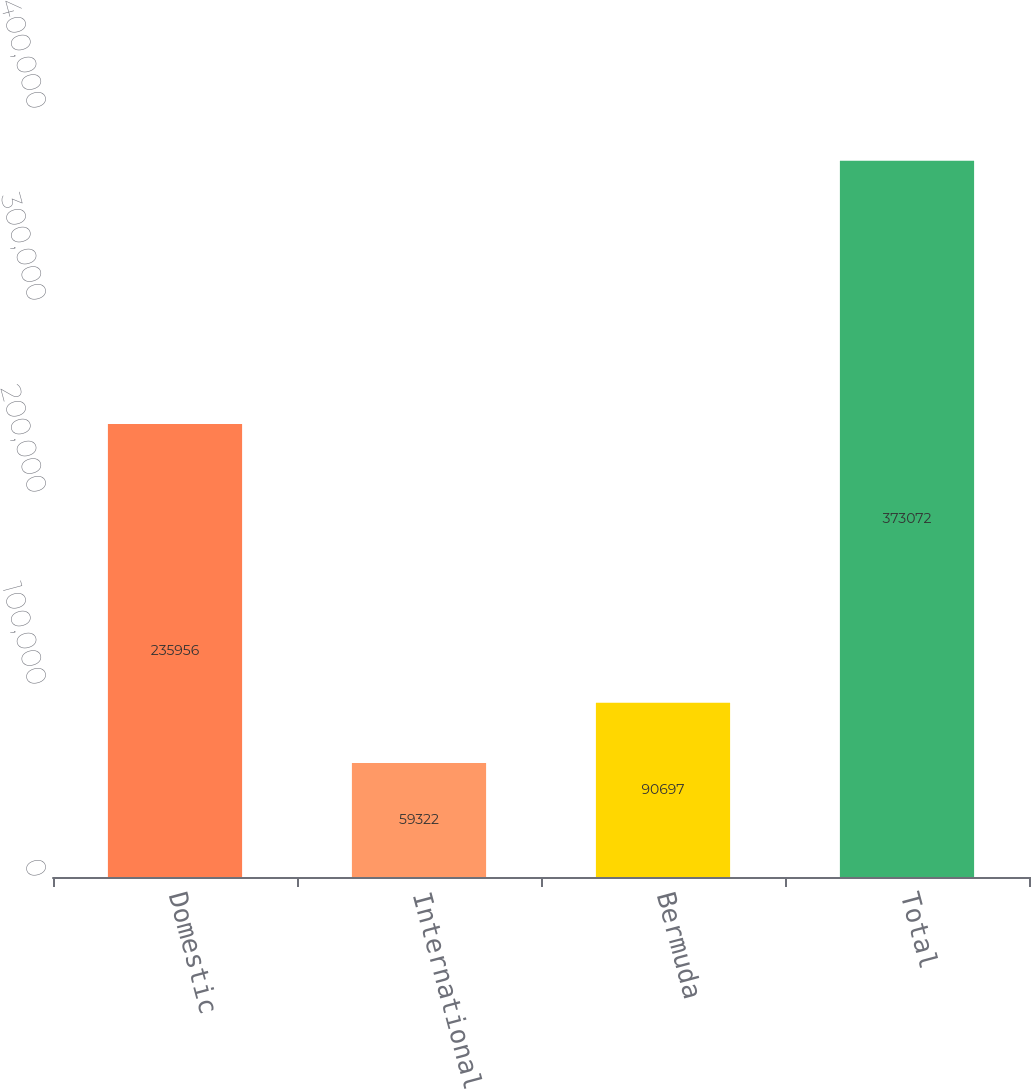Convert chart. <chart><loc_0><loc_0><loc_500><loc_500><bar_chart><fcel>Domestic<fcel>International<fcel>Bermuda<fcel>Total<nl><fcel>235956<fcel>59322<fcel>90697<fcel>373072<nl></chart> 